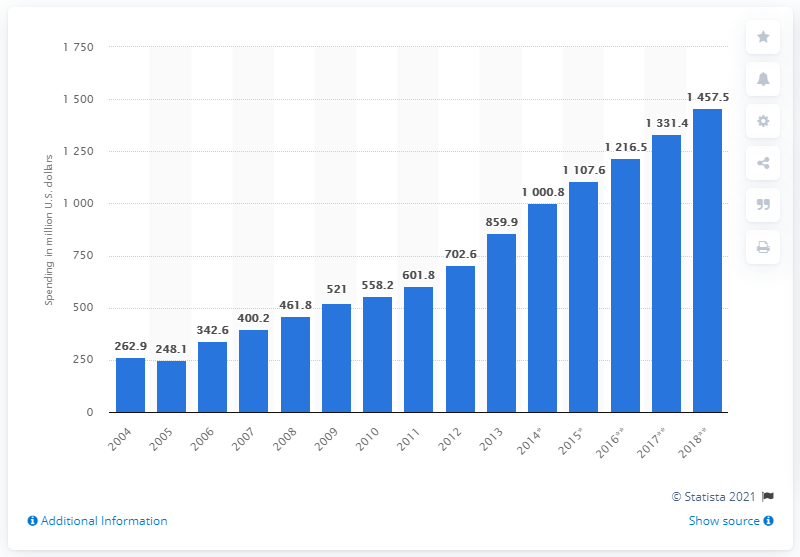Can you describe any significant changes or events that might be reflected in the ad expenditure trend in Vietnam? Significant spikes in ad expenditure in the bar chart may correspond to key economic developments or policy changes in Vietnam that affected consumer behavior and investment in advertising. For instance, rapid digitalization, improvements in business environment, or international events held in Vietnam could have played a role in increased ad spending seen in certain years. 